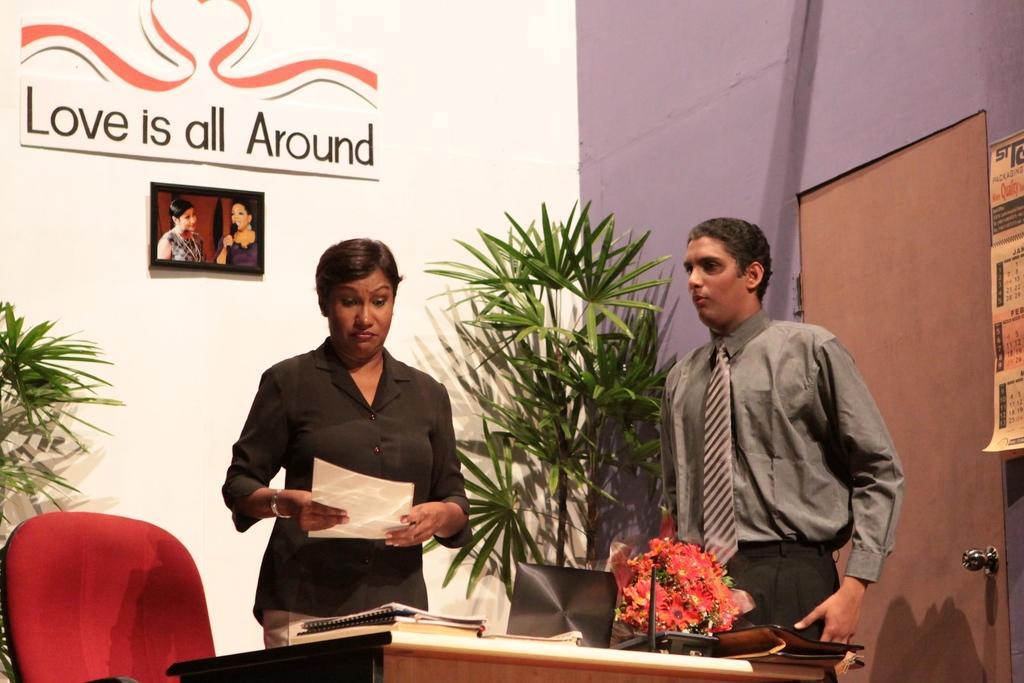Could you give a brief overview of what you see in this image? In this image I can see a woman and a man who are standing on the floor. Here we have two plants and a door. On the table we have books and some other objects on it. The woman is holding a piece of paper in her hands, and here we have red color chair. 